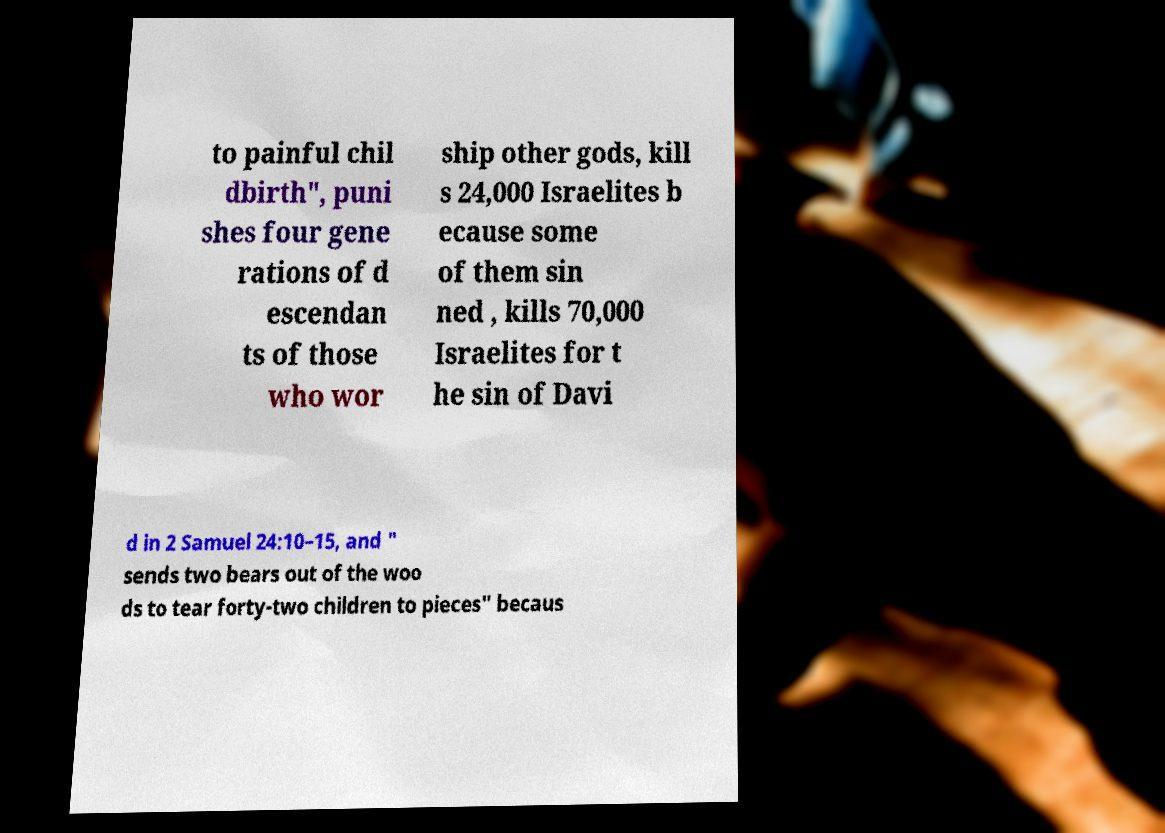Could you assist in decoding the text presented in this image and type it out clearly? to painful chil dbirth", puni shes four gene rations of d escendan ts of those who wor ship other gods, kill s 24,000 Israelites b ecause some of them sin ned , kills 70,000 Israelites for t he sin of Davi d in 2 Samuel 24:10–15, and " sends two bears out of the woo ds to tear forty-two children to pieces" becaus 